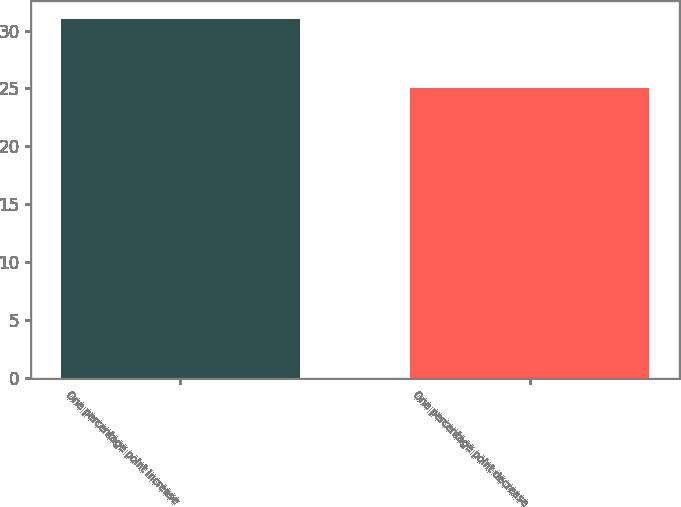<chart> <loc_0><loc_0><loc_500><loc_500><bar_chart><fcel>One percentage point increase<fcel>One percentage point decrease<nl><fcel>31<fcel>25<nl></chart> 